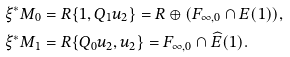<formula> <loc_0><loc_0><loc_500><loc_500>\xi ^ { * } M _ { 0 } & = R \{ 1 , Q _ { 1 } u _ { 2 } \} = R \oplus ( F _ { \infty , 0 } \cap { E } ( 1 ) ) , \\ \xi ^ { * } M _ { 1 } & = R \{ Q _ { 0 } u _ { 2 } , u _ { 2 } \} = F _ { \infty , 0 } \cap \widehat { E } ( 1 ) .</formula> 